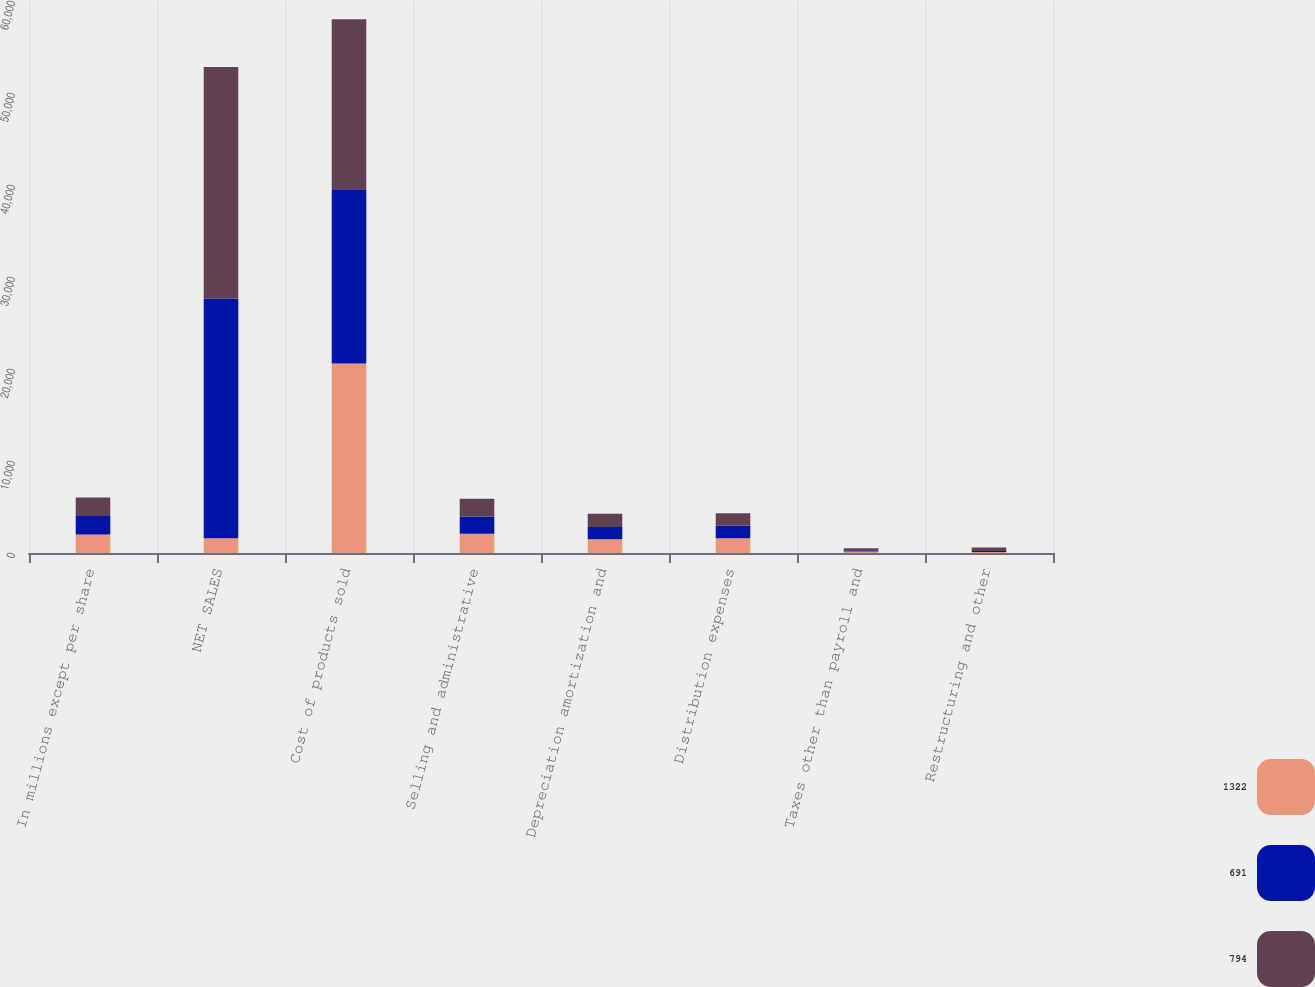Convert chart. <chart><loc_0><loc_0><loc_500><loc_500><stacked_bar_chart><ecel><fcel>In millions except per share<fcel>NET SALES<fcel>Cost of products sold<fcel>Selling and administrative<fcel>Depreciation amortization and<fcel>Distribution expenses<fcel>Taxes other than payroll and<fcel>Restructuring and other<nl><fcel>1322<fcel>2012<fcel>1611<fcel>20587<fcel>2092<fcel>1486<fcel>1611<fcel>166<fcel>109<nl><fcel>691<fcel>2011<fcel>26034<fcel>18960<fcel>1887<fcel>1332<fcel>1390<fcel>146<fcel>102<nl><fcel>794<fcel>2010<fcel>25179<fcel>18482<fcel>1930<fcel>1456<fcel>1318<fcel>192<fcel>394<nl></chart> 